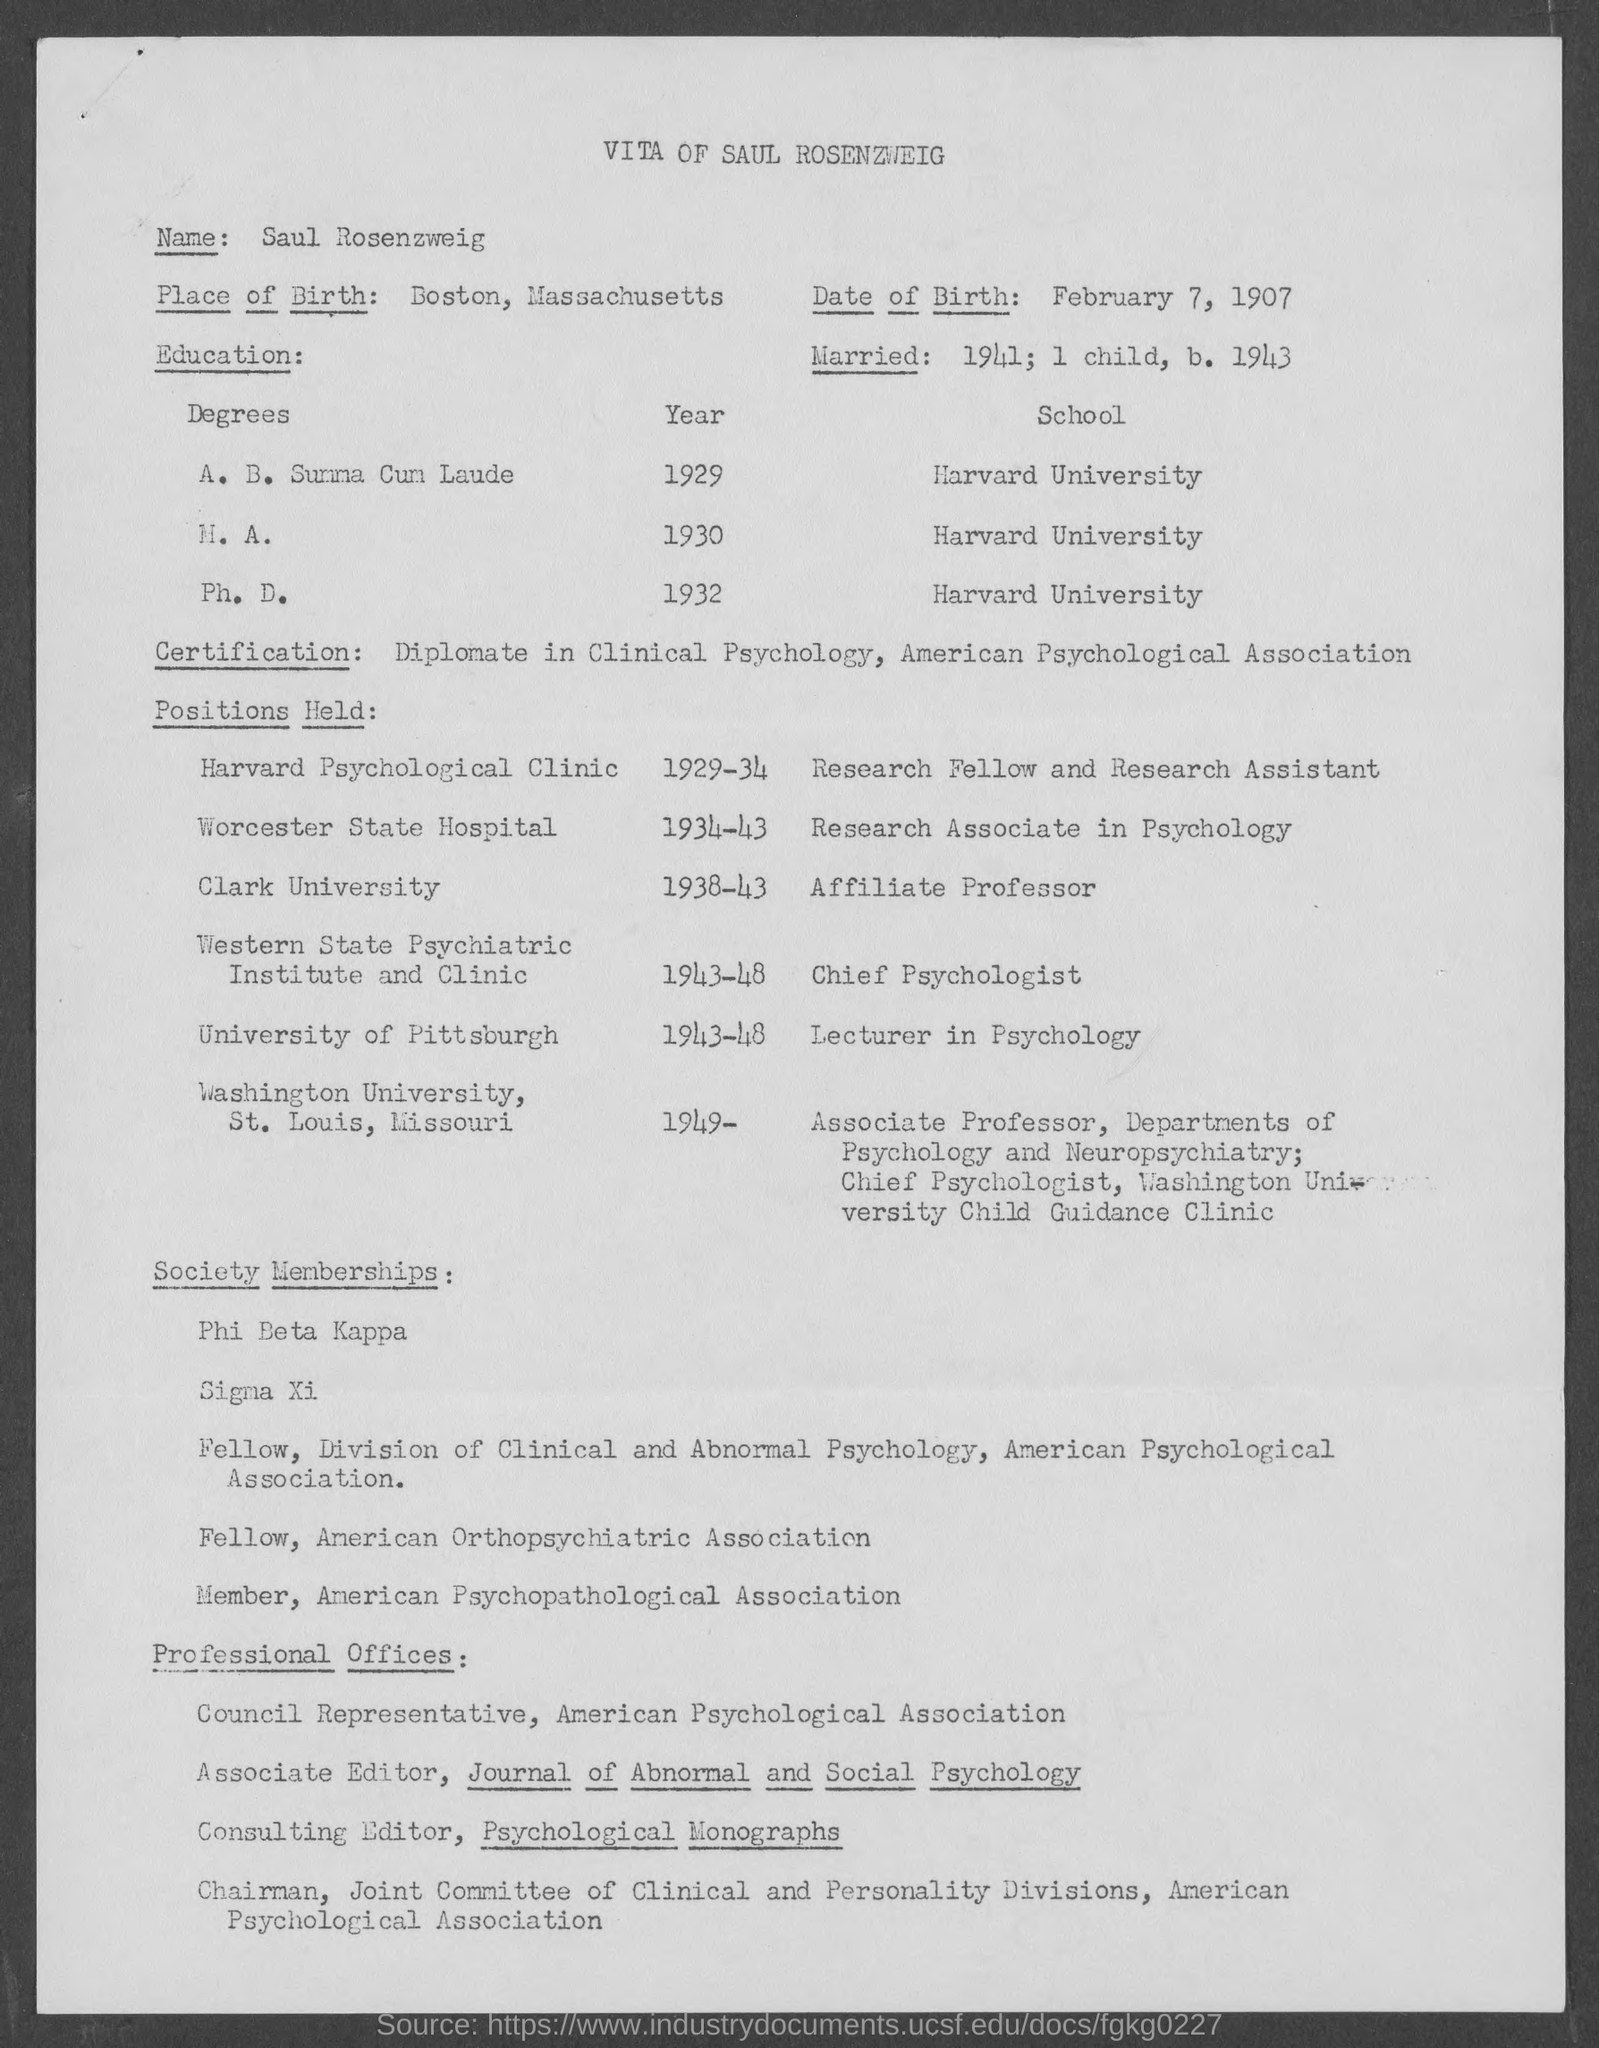What professional roles did he hold after receiving his degree? After earning his Ph.D., he took on various roles in the field of psychology. He worked at the Harvard Psychological Clinic, the Worcester State Hospital, and held positions at Clark University, Western State Psychiatric Institute and Clinic, University of Pittsburgh, and Washington University in St. Louis, Missouri. 